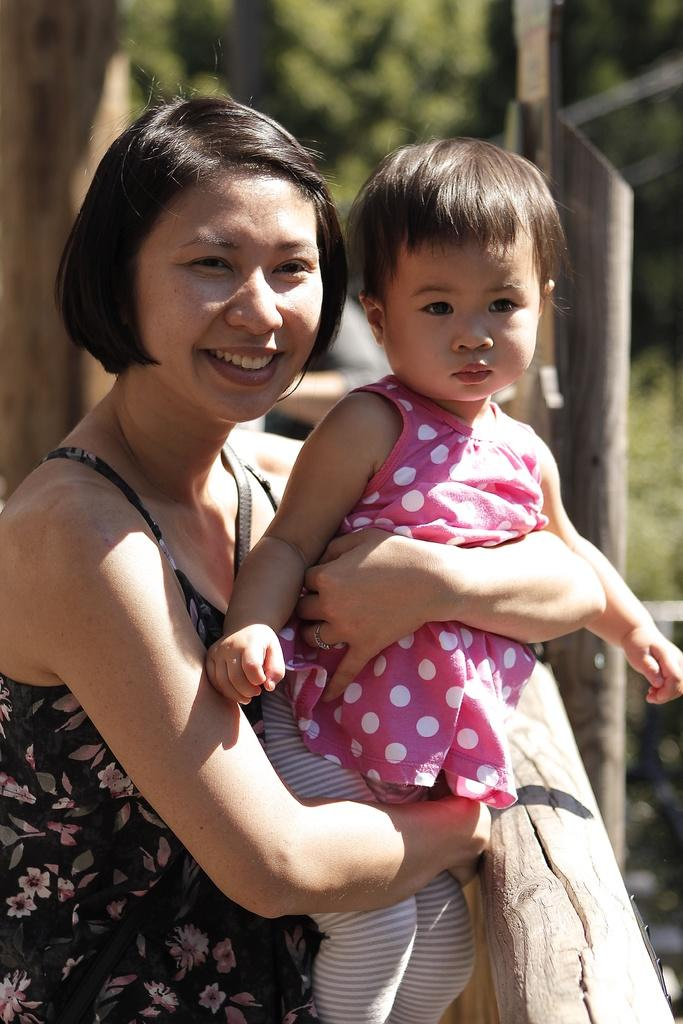Who is the main subject in the image? There is a woman in the image. What is the woman doing in the image? The woman is holding a kid with her hands. What is the woman's facial expression in the image? The woman is smiling. Can you describe the background of the image? The background of the image is blurred, and there is greenery visible. What type of fact can be seen on the woman's lip in the image? There is no fact visible on the woman's lip in the image. Is the woman experiencing any pain in the image? There is no indication of pain in the woman's facial expression or body language in the image. 